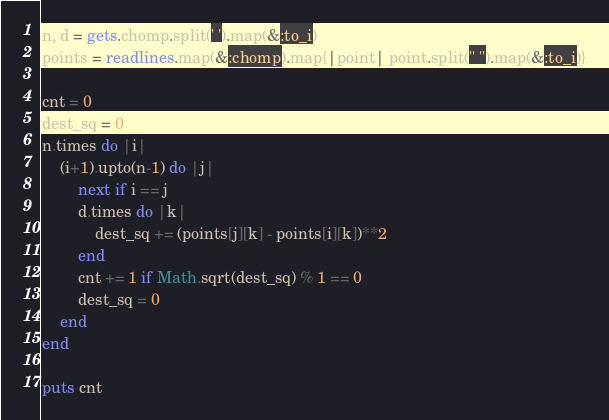Convert code to text. <code><loc_0><loc_0><loc_500><loc_500><_Ruby_>n, d = gets.chomp.split(' ').map(&:to_i)
points = readlines.map(&:chomp).map{|point| point.split(" ").map(&:to_i)}

cnt = 0
dest_sq = 0
n.times do |i|
    (i+1).upto(n-1) do |j|
        next if i == j
        d.times do |k|
            dest_sq += (points[j][k] - points[i][k])**2
        end
        cnt += 1 if Math.sqrt(dest_sq) % 1 == 0
        dest_sq = 0
    end
end

puts cnt</code> 